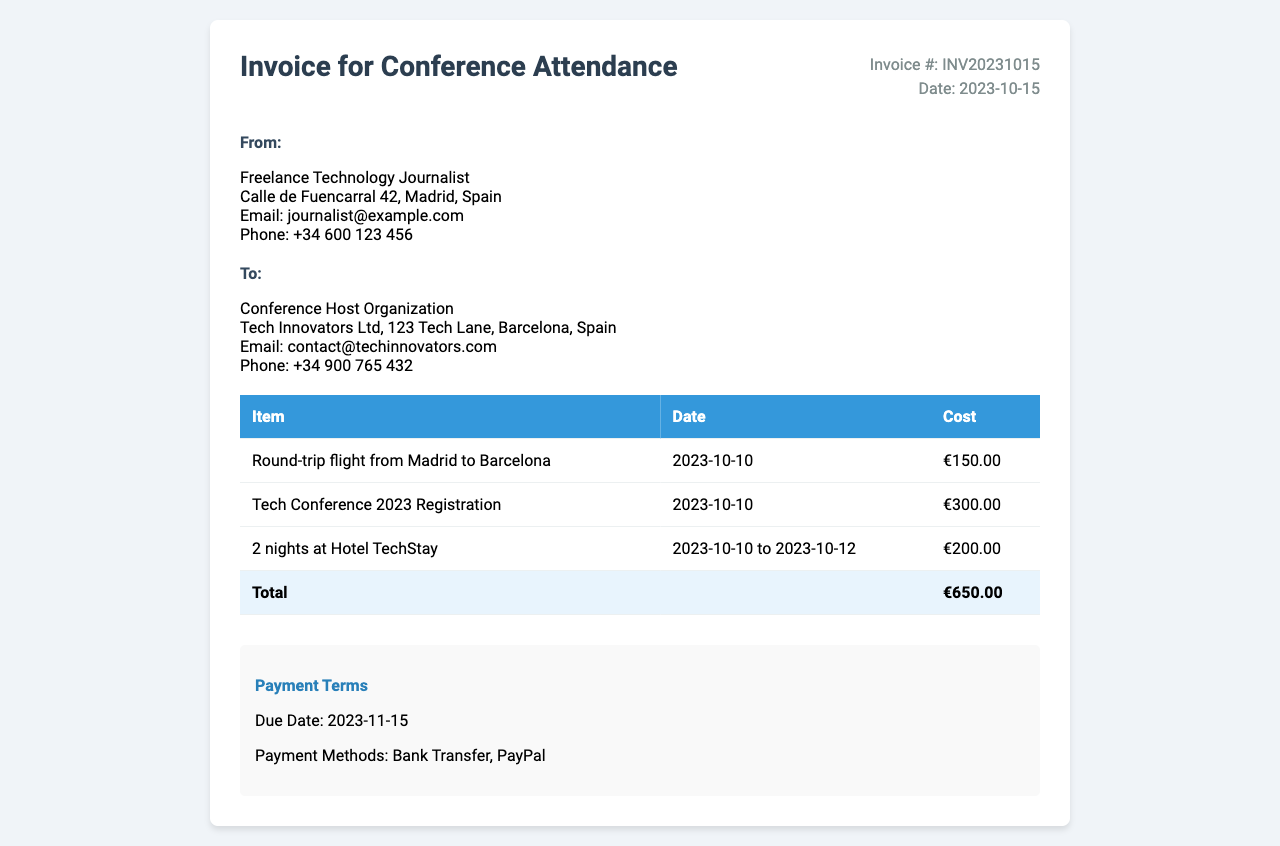What is the invoice number? The invoice number is listed in the document and reads "Invoice #: INV20231015".
Answer: INV20231015 What is the date of the invoice? The date of the invoice is provided and can be found next to the invoice number, which indicates "Date: 2023-10-15".
Answer: 2023-10-15 What is the total cost of the expenses? The document outlines various expenses and the total can be found at the bottom of the expense table, stating "Total €650.00".
Answer: €650.00 Who is the recipient of this invoice? The recipient's information is located in the "To" section of the document, which mentions "Conference Host Organization".
Answer: Conference Host Organization How many nights did the accommodation last? The accommodation is described in the expense table, stating "2 nights at Hotel TechStay".
Answer: 2 nights What is the due date for payment? The payment terms section outlines the due date as "Due Date: 2023-11-15".
Answer: 2023-11-15 What is the cost of the conference registration? The expense table lists the cost for "Tech Conference 2023 Registration" as €300.00.
Answer: €300.00 Which methods of payment are accepted? The payment terms section specifies the payment methods available. It states "Bank Transfer, PayPal".
Answer: Bank Transfer, PayPal What city did the round-trip flight depart from? The round-trip flight details are listed, stating the departure city as "Madrid".
Answer: Madrid 